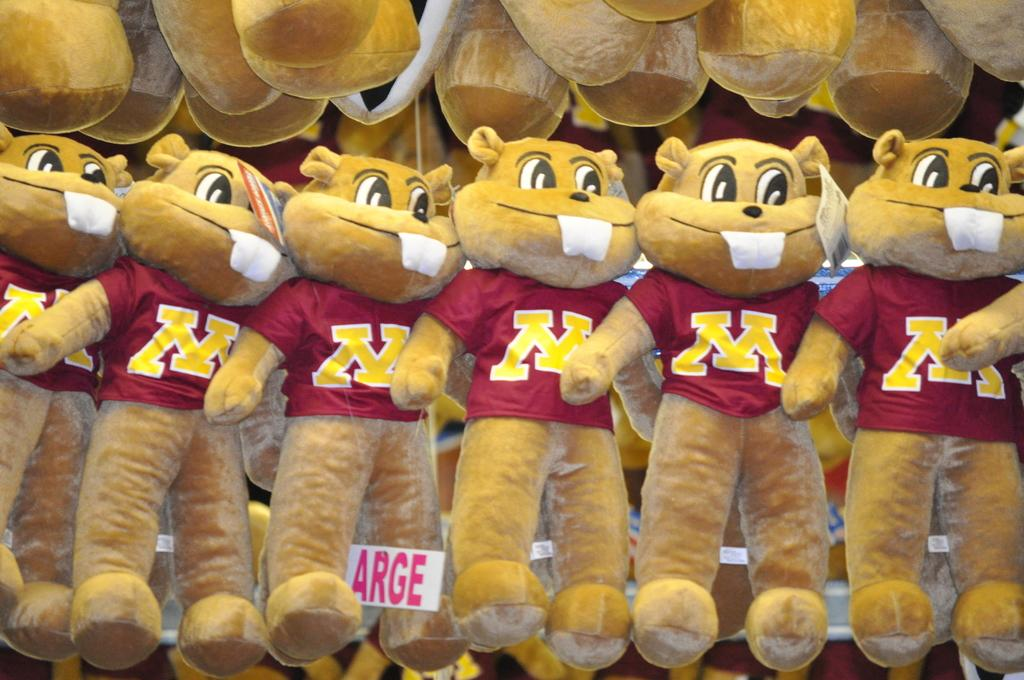What type of stuffed animals are in the image? There are teddy bears in the image. How are the teddy bears positioned in the image? The teddy bears are hanging over a place. What type of cork can be seen in the image? There is no cork present in the image. What is the exchange rate between the teddy bears in the image? There is no exchange rate mentioned or implied in the image, as it features teddy bears hanging over a place. 